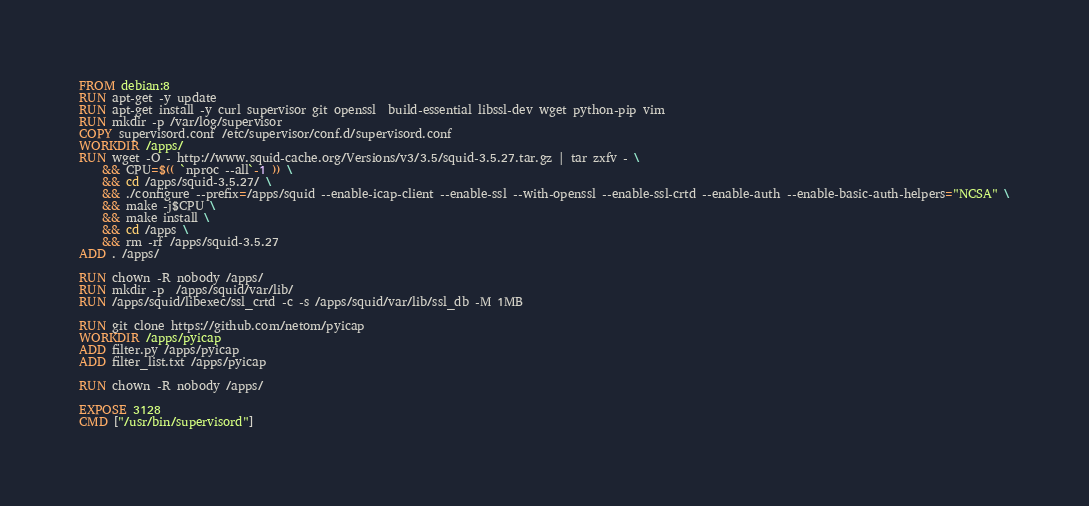<code> <loc_0><loc_0><loc_500><loc_500><_Dockerfile_>FROM debian:8
RUN apt-get -y update
RUN apt-get install -y curl supervisor git openssl  build-essential libssl-dev wget python-pip vim
RUN mkdir -p /var/log/supervisor
COPY supervisord.conf /etc/supervisor/conf.d/supervisord.conf
WORKDIR /apps/
RUN wget -O - http://www.squid-cache.org/Versions/v3/3.5/squid-3.5.27.tar.gz | tar zxfv - \
    && CPU=$(( `nproc --all`-1 )) \
    && cd /apps/squid-3.5.27/ \
    && ./configure --prefix=/apps/squid --enable-icap-client --enable-ssl --with-openssl --enable-ssl-crtd --enable-auth --enable-basic-auth-helpers="NCSA" \
    && make -j$CPU \
    && make install \
    && cd /apps \
    && rm -rf /apps/squid-3.5.27
ADD . /apps/

RUN chown -R nobody /apps/
RUN mkdir -p  /apps/squid/var/lib/
RUN /apps/squid/libexec/ssl_crtd -c -s /apps/squid/var/lib/ssl_db -M 1MB

RUN git clone https://github.com/netom/pyicap
WORKDIR /apps/pyicap
ADD filter.py /apps/pyicap
ADD filter_list.txt /apps/pyicap

RUN chown -R nobody /apps/

EXPOSE 3128
CMD ["/usr/bin/supervisord"]

</code> 